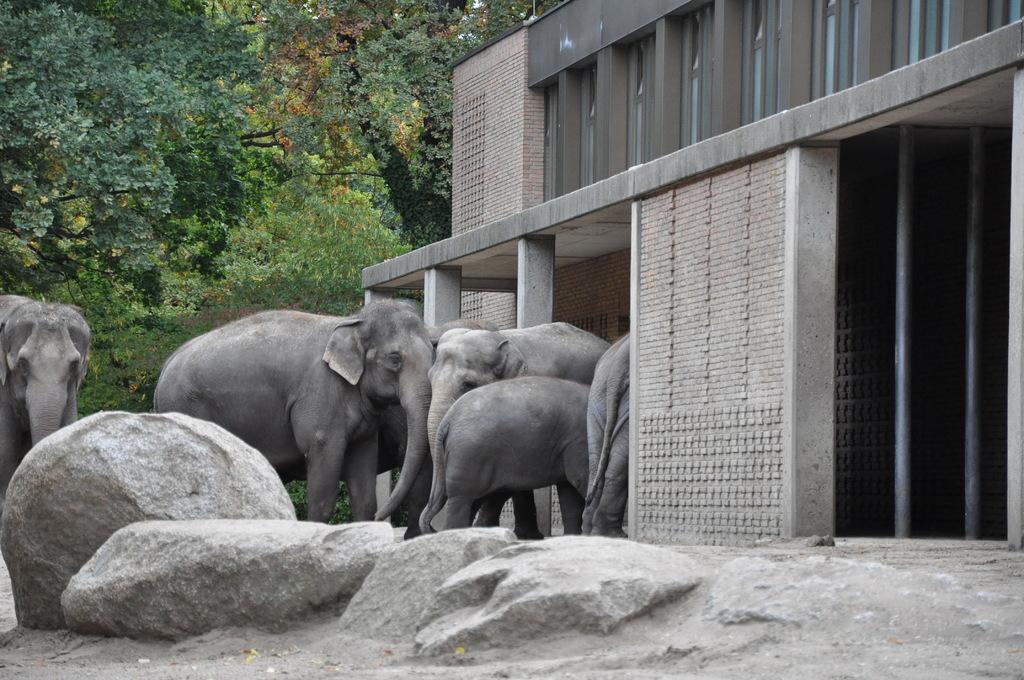How would you summarize this image in a sentence or two? In this image there are many elephants. On the right there is a building. In the ground there are stones. In the background there are trees. 